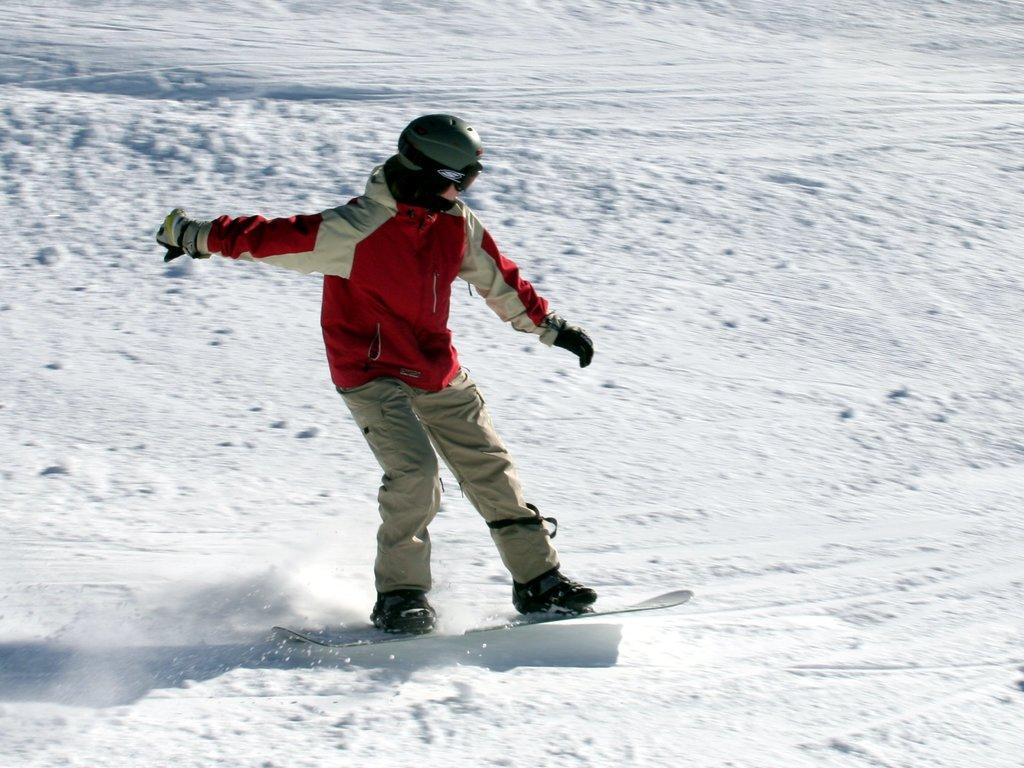Describe this image in one or two sentences. In this image, in the middle, we can see a person riding on the ski board. In the background, we can see a snow. 